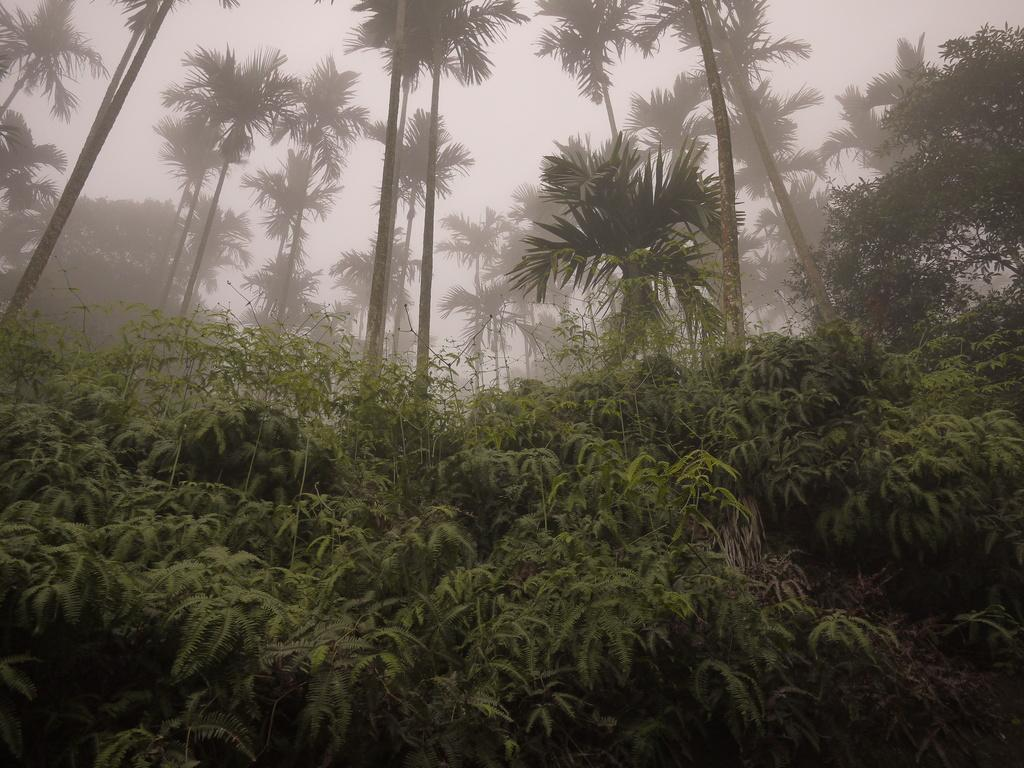What type of vegetation is present in the image? There is a group of plants and trees in the image. What else can be seen in the image besides the plants and trees? The sky is visible in the image. How would you describe the sky in the image? The sky appears to be cloudy in the image. Where is the toothbrush located in the image? There is no toothbrush present in the image. Is there a boat visible in the image? There is no boat present in the image. 